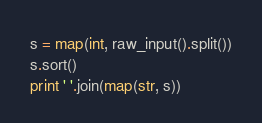Convert code to text. <code><loc_0><loc_0><loc_500><loc_500><_Python_>s = map(int, raw_input().split())
s.sort()
print ' '.join(map(str, s))</code> 